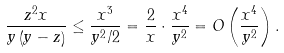Convert formula to latex. <formula><loc_0><loc_0><loc_500><loc_500>\frac { z ^ { 2 } x } { y \left ( y - z \right ) } & \leq \frac { x ^ { 3 } } { y ^ { 2 } / 2 } = \frac { 2 } { x } \cdot \frac { x ^ { 4 } } { y ^ { 2 } } = O \left ( \frac { x ^ { 4 } } { y ^ { 2 } } \right ) .</formula> 